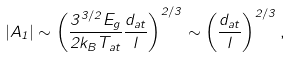Convert formula to latex. <formula><loc_0><loc_0><loc_500><loc_500>| A _ { 1 } | \sim \left ( \frac { 3 ^ { 3 / 2 } E _ { g } } { 2 k _ { B } T _ { a t } } \frac { d _ { a t } } { l } \right ) ^ { 2 / 3 } \sim \left ( \frac { d _ { a t } } { l } \right ) ^ { 2 / 3 } ,</formula> 